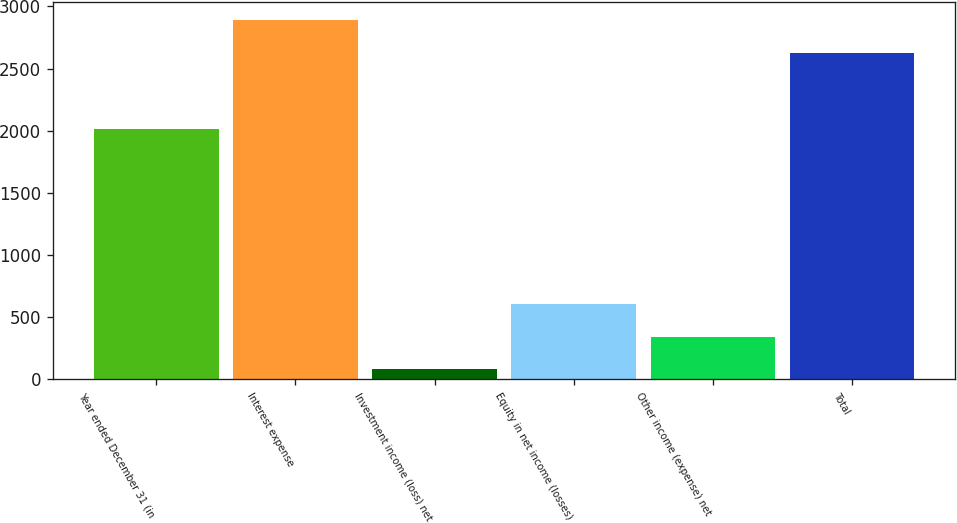<chart> <loc_0><loc_0><loc_500><loc_500><bar_chart><fcel>Year ended December 31 (in<fcel>Interest expense<fcel>Investment income (loss) net<fcel>Equity in net income (losses)<fcel>Other income (expense) net<fcel>Total<nl><fcel>2015<fcel>2888.1<fcel>81<fcel>605.2<fcel>343.1<fcel>2626<nl></chart> 